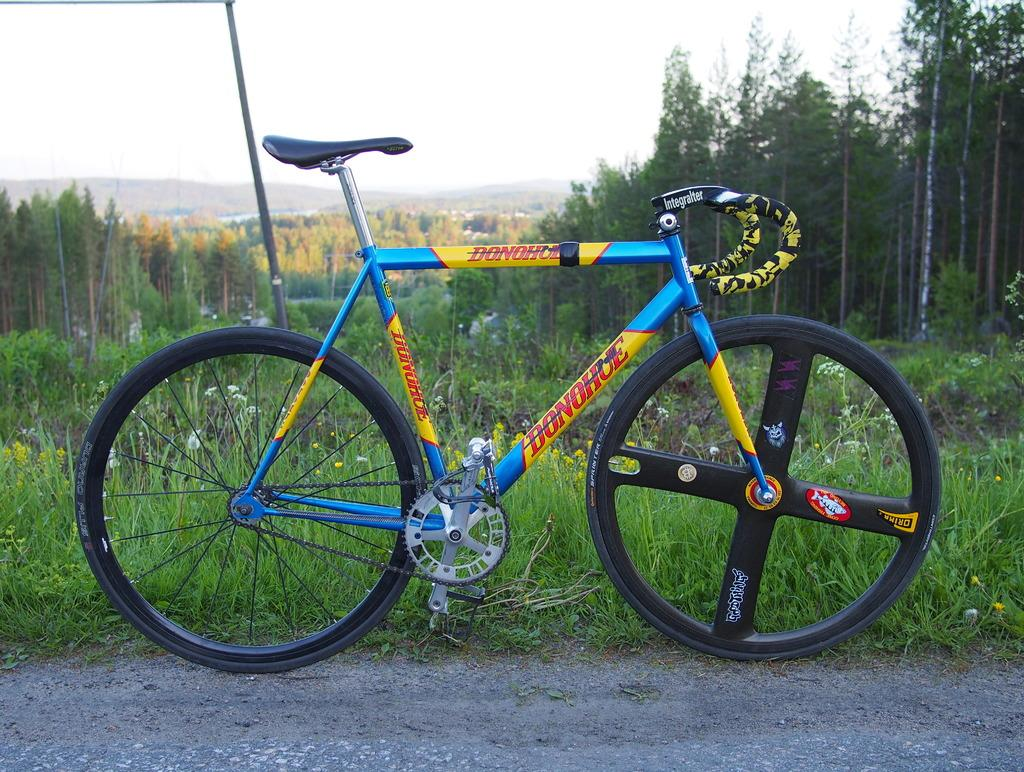What color is the bicycle in the image? The bicycle in the image is blue and yellow. What is located behind the bicycle? There is a pillar behind the bicycle. What type of natural environment is visible in the image? There are many trees visible in the image. What type of pencil can be seen in the image? There is no pencil present in the image. 